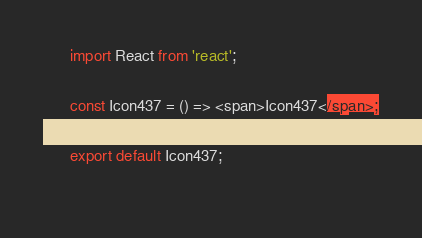Convert code to text. <code><loc_0><loc_0><loc_500><loc_500><_JavaScript_>
      import React from 'react';

      const Icon437 = () => <span>Icon437</span>;
      
      export default Icon437;
    </code> 